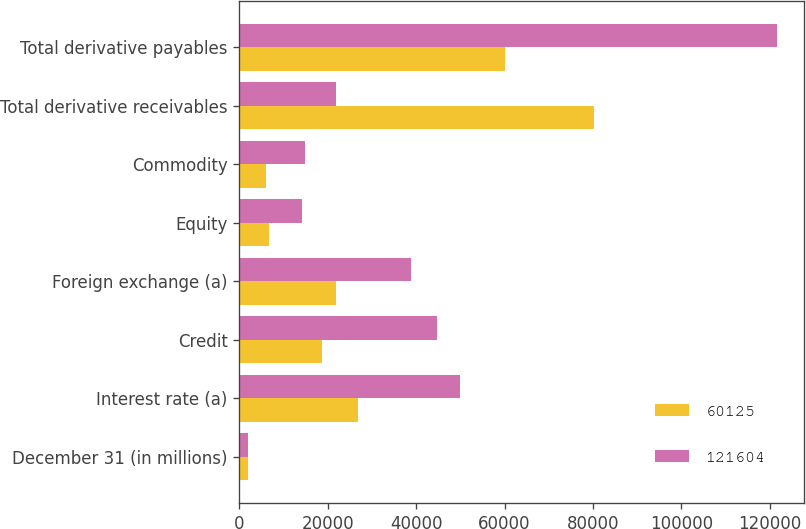Convert chart to OTSL. <chart><loc_0><loc_0><loc_500><loc_500><stacked_bar_chart><ecel><fcel>December 31 (in millions)<fcel>Interest rate (a)<fcel>Credit<fcel>Foreign exchange (a)<fcel>Equity<fcel>Commodity<fcel>Total derivative receivables<fcel>Total derivative payables<nl><fcel>60125<fcel>2009<fcel>26777<fcel>18815<fcel>21984<fcel>6635<fcel>5999<fcel>80210<fcel>60125<nl><fcel>121604<fcel>2008<fcel>49996<fcel>44695<fcel>38820<fcel>14285<fcel>14830<fcel>21984<fcel>121604<nl></chart> 